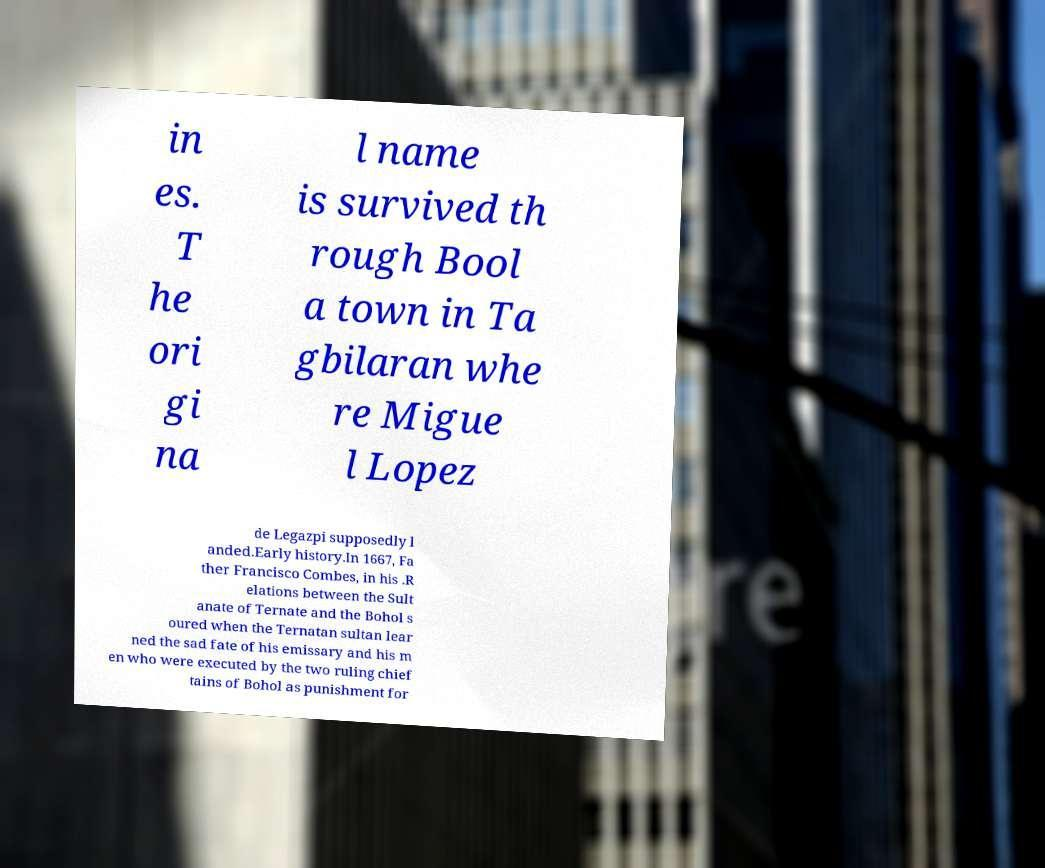Please identify and transcribe the text found in this image. in es. T he ori gi na l name is survived th rough Bool a town in Ta gbilaran whe re Migue l Lopez de Legazpi supposedly l anded.Early history.In 1667, Fa ther Francisco Combes, in his .R elations between the Sult anate of Ternate and the Bohol s oured when the Ternatan sultan lear ned the sad fate of his emissary and his m en who were executed by the two ruling chief tains of Bohol as punishment for 